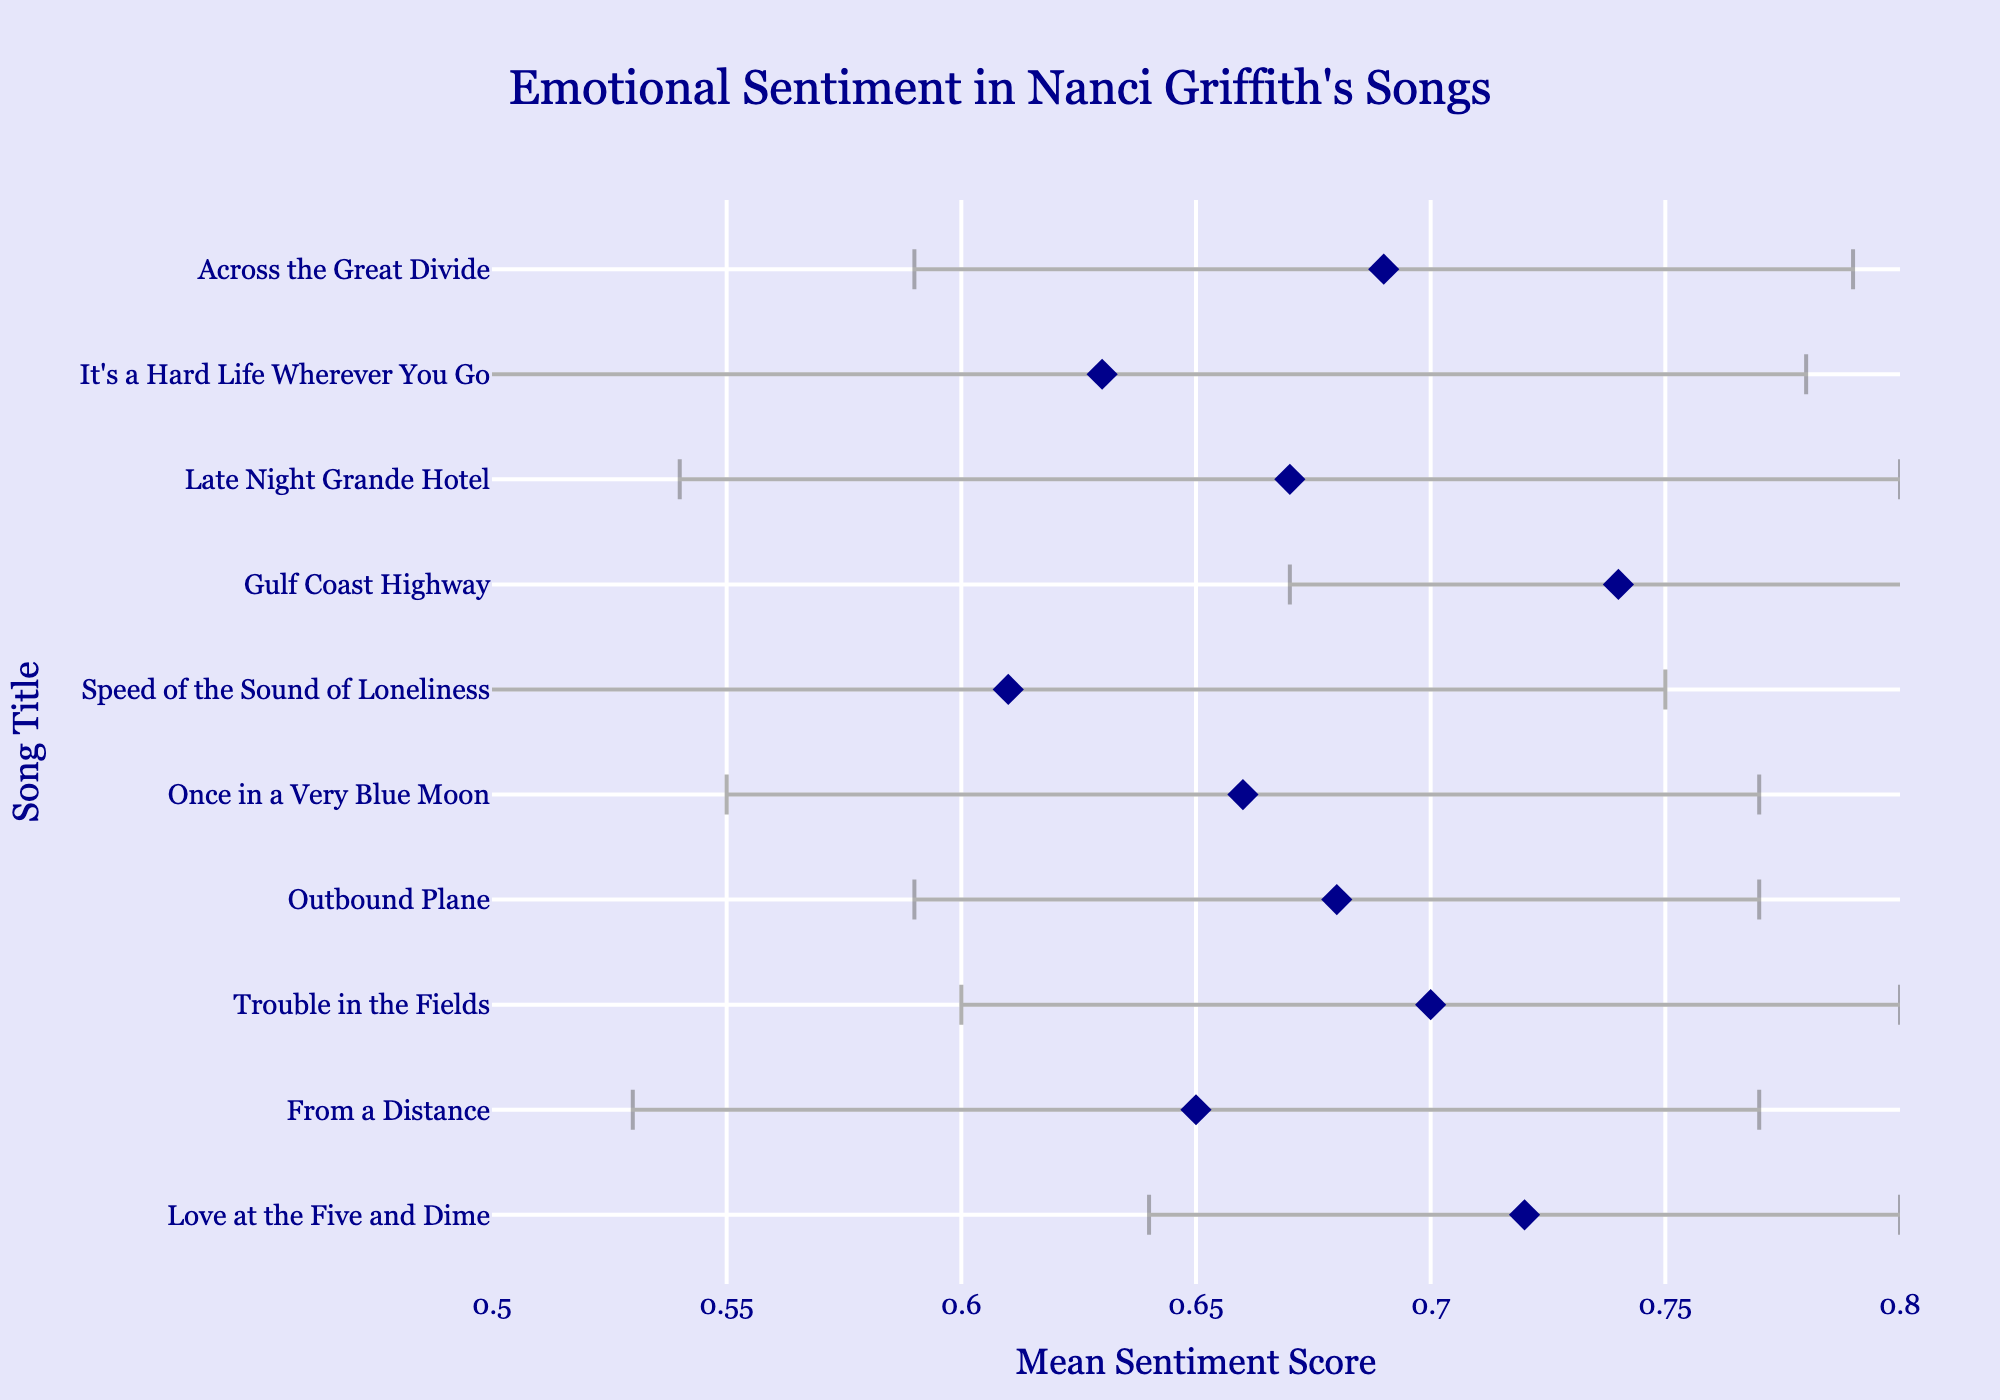What's the title of the plot? The title of the plot is displayed prominently at the top of the figure. The figure presents the title in a font that is both stylish and readable, emphasizing the subject matter of the visualization.
Answer: Emotional Sentiment in Nanci Griffith's Songs What is the song with the highest mean sentiment score? By examining the x-axis values and the data points, we can identify which song has the highest mean sentiment score. The one with the score closest to 0.8 is the highest.
Answer: Gulf Coast Highway Which song has the largest error bar? Error bars are visual elements that extend horizontally from each dot. The one with the longest spread indicates the largest standard deviation. By comparing the lengths, we see which one is the longest.
Answer: It's a Hard Life Wherever You Go How many songs have a mean sentiment score above 0.70? To answer this, count the number of data points that lie to the right of the 0.70 mark on the x-axis. Each point represents a song.
Answer: 3 What is the mean sentiment score of 'Outbound Plane'? Locate the position of 'Outbound Plane' on the y-axis and see where the dot aligns on the x-axis. The exact value can be directly read from the figure.
Answer: 0.68 Which song has the lowest mean sentiment score? By identifying the data point closest to the left end of the x-axis, we find the song with the smallest mean sentiment score.
Answer: Speed of the Sound of Loneliness Compare the mean sentiment scores of 'From a Distance' and 'Once in a Very Blue Moon'. Which one is higher? Locate the positions of both songs on the y-axis and compare their respective x-axis values.
Answer: From a Distance What is the mean sentiment score difference between 'Love at the Five and Dime' and 'Outbound Plane'? Subtract the mean sentiment score of 'Outbound Plane' from that of 'Love at the Five and Dime'. This involves simple subtraction based on their positions on the x-axis.
Answer: 0.04 What color and shape are the data points represented as? The figure uses a specific style for the data points which can be determined by their visual appearance. The color and shape are clearly visible.
Answer: Dark blue diamonds What's the range of the x-axis in the plot? By looking at the scale on the x-axis, we determine the minimum and maximum values presented. These values define the range.
Answer: 0.5 to 0.8 